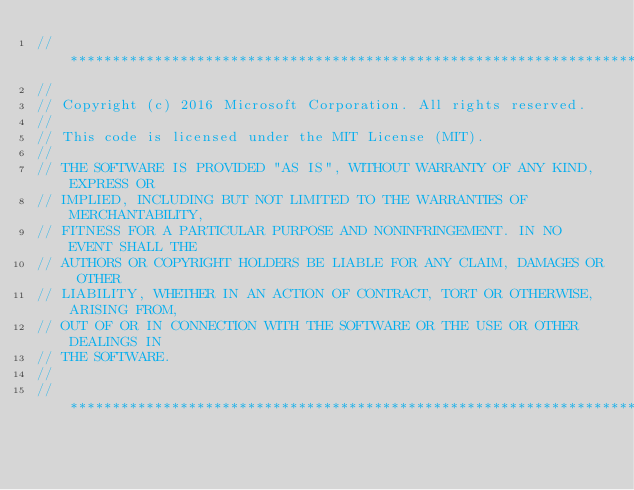Convert code to text. <code><loc_0><loc_0><loc_500><loc_500><_ObjectiveC_>//******************************************************************************
//
// Copyright (c) 2016 Microsoft Corporation. All rights reserved.
//
// This code is licensed under the MIT License (MIT).
//
// THE SOFTWARE IS PROVIDED "AS IS", WITHOUT WARRANTY OF ANY KIND, EXPRESS OR
// IMPLIED, INCLUDING BUT NOT LIMITED TO THE WARRANTIES OF MERCHANTABILITY,
// FITNESS FOR A PARTICULAR PURPOSE AND NONINFRINGEMENT. IN NO EVENT SHALL THE
// AUTHORS OR COPYRIGHT HOLDERS BE LIABLE FOR ANY CLAIM, DAMAGES OR OTHER
// LIABILITY, WHETHER IN AN ACTION OF CONTRACT, TORT OR OTHERWISE, ARISING FROM,
// OUT OF OR IN CONNECTION WITH THE SOFTWARE OR THE USE OR OTHER DEALINGS IN
// THE SOFTWARE.
//
//******************************************************************************</code> 